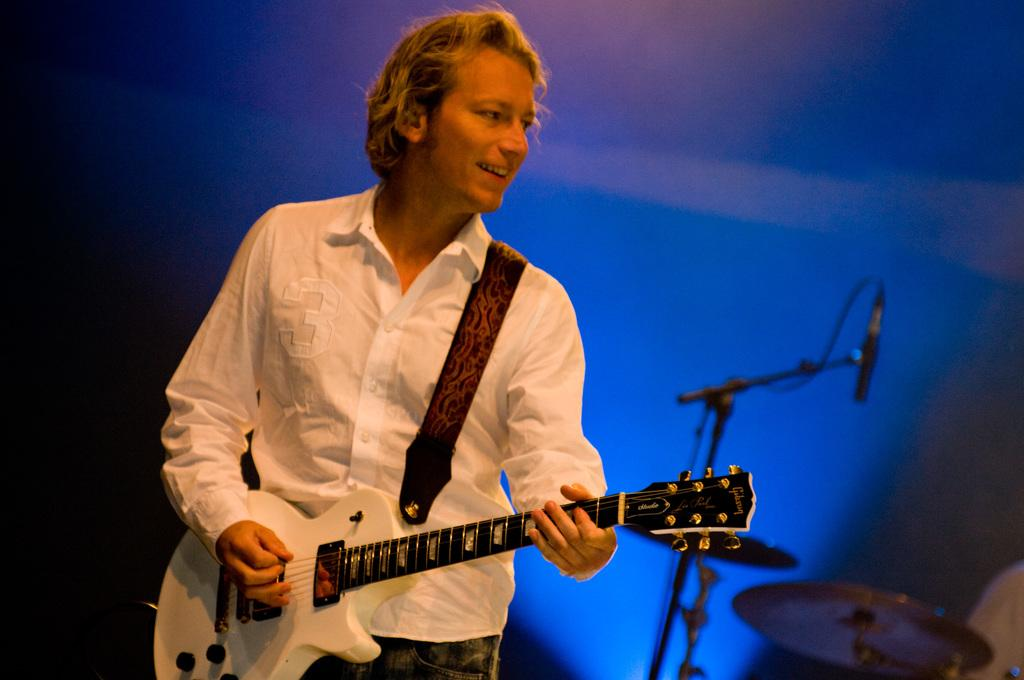What is the man in the image doing? The man is playing a guitar in the image. What is the man's facial expression? The man is smiling in the image. What other musical instruments can be seen in the image? There are other musical instruments visible behind the man. How is the background of the man depicted? The background of the man is blurred in the image. What type of fowl can be seen interacting with the man and his guitar in the image? There is no fowl present in the image; it only features the man playing a guitar and other musical instruments. What is the level of friction between the man's fingers and the guitar strings in the image? The image does not provide information about the level of friction between the man's fingers and the guitar strings. 